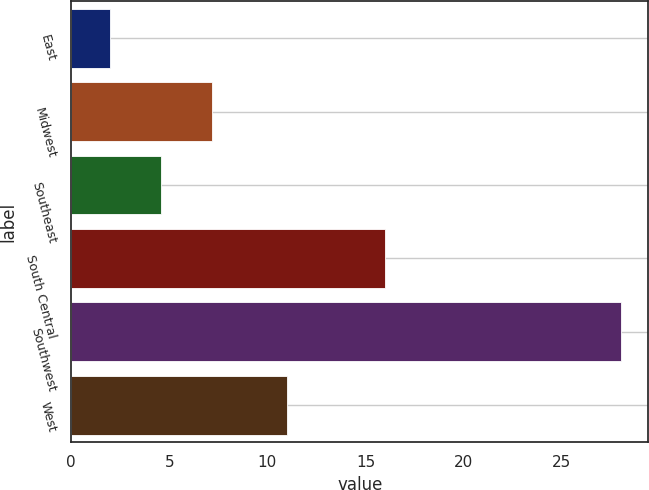Convert chart to OTSL. <chart><loc_0><loc_0><loc_500><loc_500><bar_chart><fcel>East<fcel>Midwest<fcel>Southeast<fcel>South Central<fcel>Southwest<fcel>West<nl><fcel>2<fcel>7.2<fcel>4.6<fcel>16<fcel>28<fcel>11<nl></chart> 